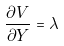<formula> <loc_0><loc_0><loc_500><loc_500>\frac { \partial V } { \partial Y } = \lambda</formula> 